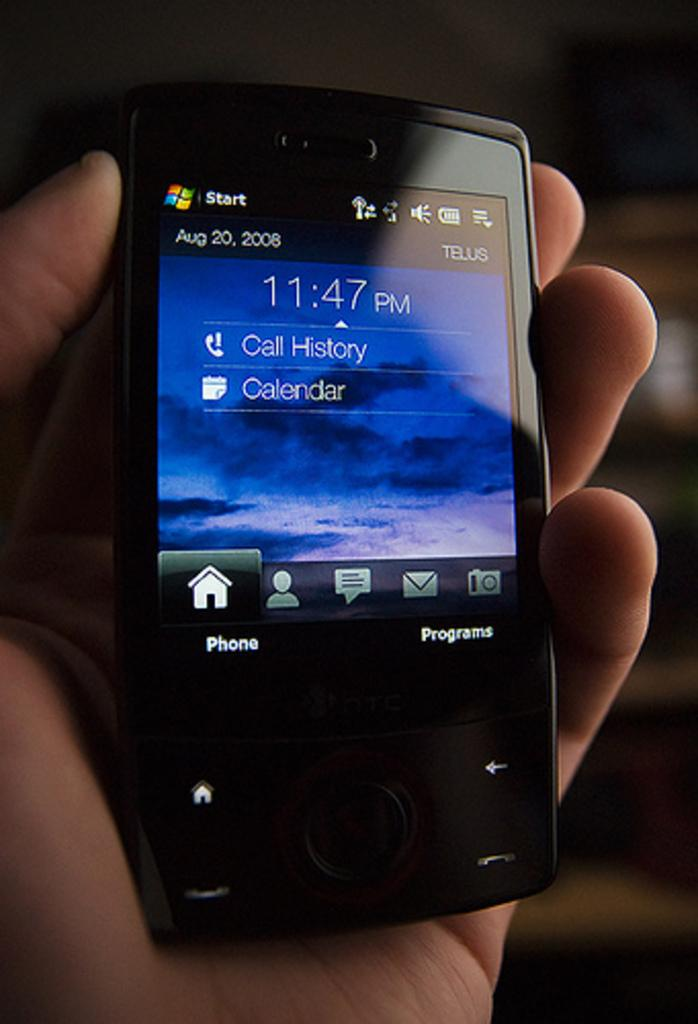Provide a one-sentence caption for the provided image. A phone display screen shows the time of 11:47 PM, and sections for Calendar and Call History. 